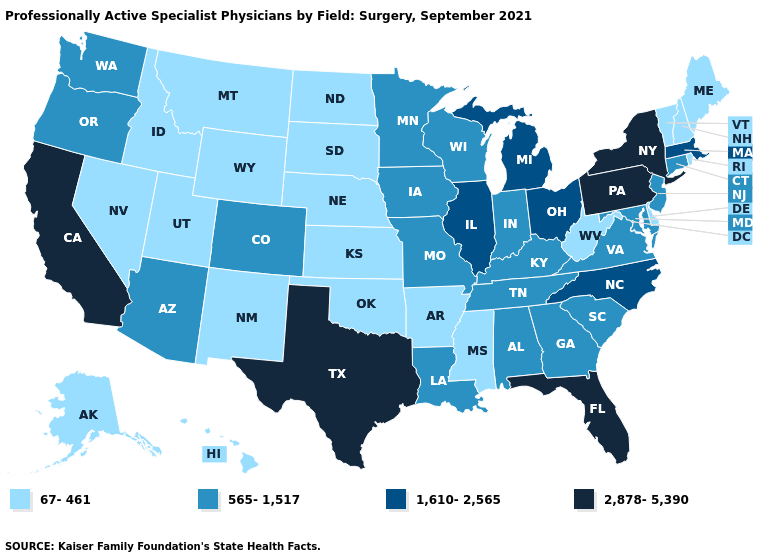What is the lowest value in the South?
Short answer required. 67-461. What is the value of Montana?
Keep it brief. 67-461. Name the states that have a value in the range 67-461?
Give a very brief answer. Alaska, Arkansas, Delaware, Hawaii, Idaho, Kansas, Maine, Mississippi, Montana, Nebraska, Nevada, New Hampshire, New Mexico, North Dakota, Oklahoma, Rhode Island, South Dakota, Utah, Vermont, West Virginia, Wyoming. Among the states that border Massachusetts , does Vermont have the lowest value?
Concise answer only. Yes. What is the value of Maine?
Short answer required. 67-461. Name the states that have a value in the range 565-1,517?
Be succinct. Alabama, Arizona, Colorado, Connecticut, Georgia, Indiana, Iowa, Kentucky, Louisiana, Maryland, Minnesota, Missouri, New Jersey, Oregon, South Carolina, Tennessee, Virginia, Washington, Wisconsin. Does Iowa have the lowest value in the MidWest?
Write a very short answer. No. Which states hav the highest value in the MidWest?
Be succinct. Illinois, Michigan, Ohio. What is the highest value in the USA?
Quick response, please. 2,878-5,390. What is the lowest value in the USA?
Be succinct. 67-461. Does Kansas have the lowest value in the MidWest?
Keep it brief. Yes. What is the highest value in the South ?
Write a very short answer. 2,878-5,390. Name the states that have a value in the range 1,610-2,565?
Keep it brief. Illinois, Massachusetts, Michigan, North Carolina, Ohio. What is the lowest value in the South?
Short answer required. 67-461. What is the value of New Jersey?
Be succinct. 565-1,517. 